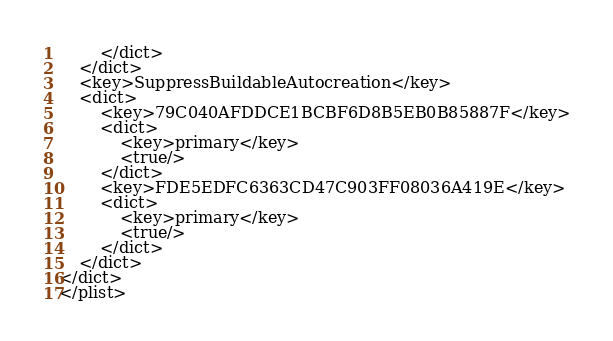Convert code to text. <code><loc_0><loc_0><loc_500><loc_500><_XML_>		</dict>
	</dict>
	<key>SuppressBuildableAutocreation</key>
	<dict>
		<key>79C040AFDDCE1BCBF6D8B5EB0B85887F</key>
		<dict>
			<key>primary</key>
			<true/>
		</dict>
		<key>FDE5EDFC6363CD47C903FF08036A419E</key>
		<dict>
			<key>primary</key>
			<true/>
		</dict>
	</dict>
</dict>
</plist>
</code> 